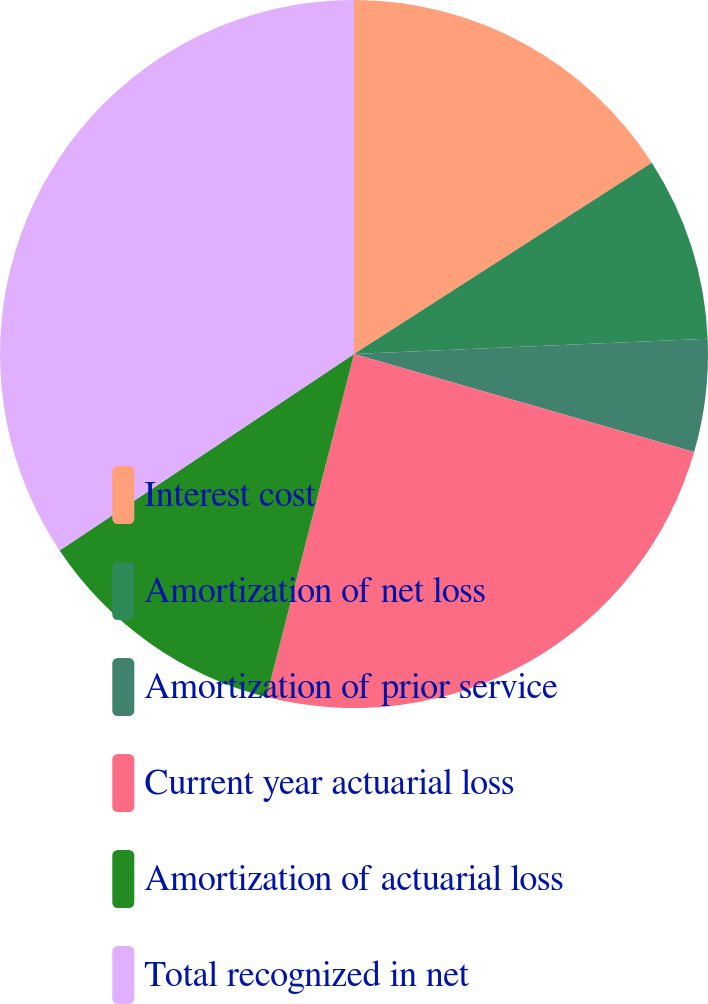Convert chart. <chart><loc_0><loc_0><loc_500><loc_500><pie_chart><fcel>Interest cost<fcel>Amortization of net loss<fcel>Amortization of prior service<fcel>Current year actuarial loss<fcel>Amortization of actuarial loss<fcel>Total recognized in net<nl><fcel>15.91%<fcel>8.4%<fcel>5.16%<fcel>24.51%<fcel>11.65%<fcel>34.37%<nl></chart> 